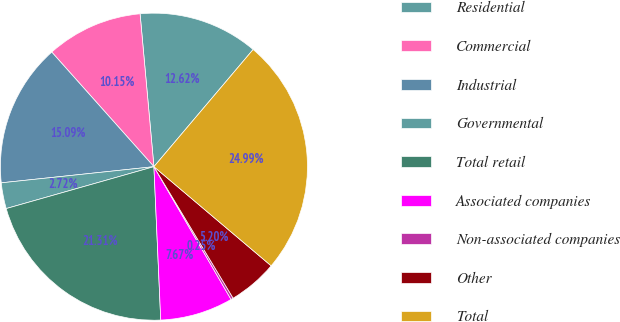<chart> <loc_0><loc_0><loc_500><loc_500><pie_chart><fcel>Residential<fcel>Commercial<fcel>Industrial<fcel>Governmental<fcel>Total retail<fcel>Associated companies<fcel>Non-associated companies<fcel>Other<fcel>Total<nl><fcel>12.62%<fcel>10.15%<fcel>15.09%<fcel>2.72%<fcel>21.31%<fcel>7.67%<fcel>0.25%<fcel>5.2%<fcel>24.99%<nl></chart> 